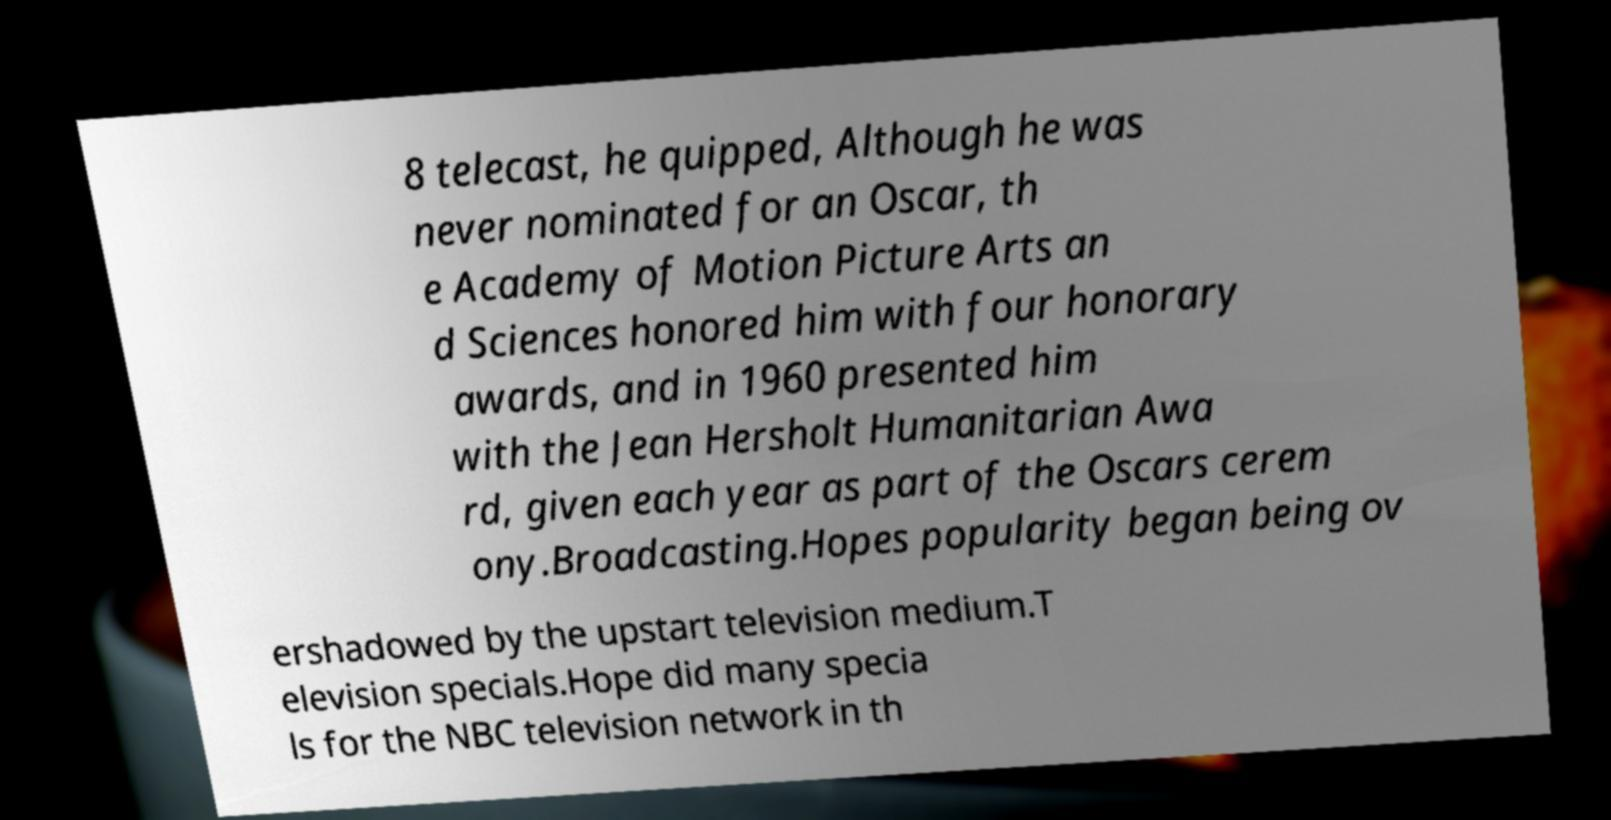I need the written content from this picture converted into text. Can you do that? 8 telecast, he quipped, Although he was never nominated for an Oscar, th e Academy of Motion Picture Arts an d Sciences honored him with four honorary awards, and in 1960 presented him with the Jean Hersholt Humanitarian Awa rd, given each year as part of the Oscars cerem ony.Broadcasting.Hopes popularity began being ov ershadowed by the upstart television medium.T elevision specials.Hope did many specia ls for the NBC television network in th 